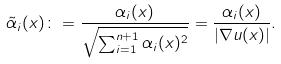<formula> <loc_0><loc_0><loc_500><loc_500>\tilde { \alpha } _ { i } ( x ) \colon = \frac { \alpha _ { i } ( x ) } { \sqrt { \sum _ { i = 1 } ^ { n + 1 } \alpha _ { i } ( x ) ^ { 2 } } } = \frac { \alpha _ { i } ( x ) } { | \nabla u ( x ) | } .</formula> 